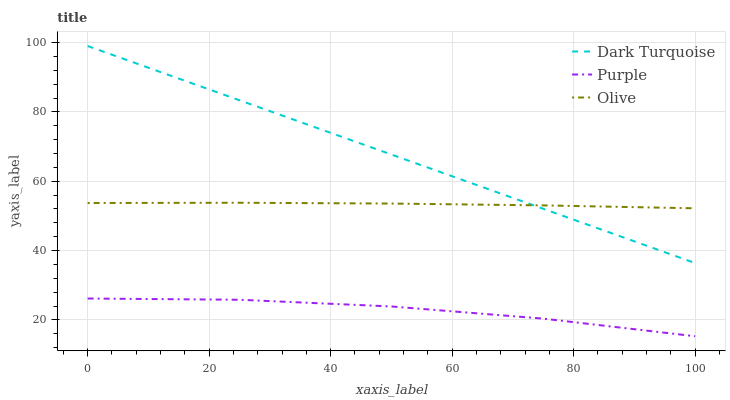Does Purple have the minimum area under the curve?
Answer yes or no. Yes. Does Dark Turquoise have the maximum area under the curve?
Answer yes or no. Yes. Does Olive have the minimum area under the curve?
Answer yes or no. No. Does Olive have the maximum area under the curve?
Answer yes or no. No. Is Dark Turquoise the smoothest?
Answer yes or no. Yes. Is Purple the roughest?
Answer yes or no. Yes. Is Olive the smoothest?
Answer yes or no. No. Is Olive the roughest?
Answer yes or no. No. Does Purple have the lowest value?
Answer yes or no. Yes. Does Dark Turquoise have the lowest value?
Answer yes or no. No. Does Dark Turquoise have the highest value?
Answer yes or no. Yes. Does Olive have the highest value?
Answer yes or no. No. Is Purple less than Dark Turquoise?
Answer yes or no. Yes. Is Dark Turquoise greater than Purple?
Answer yes or no. Yes. Does Dark Turquoise intersect Olive?
Answer yes or no. Yes. Is Dark Turquoise less than Olive?
Answer yes or no. No. Is Dark Turquoise greater than Olive?
Answer yes or no. No. Does Purple intersect Dark Turquoise?
Answer yes or no. No. 